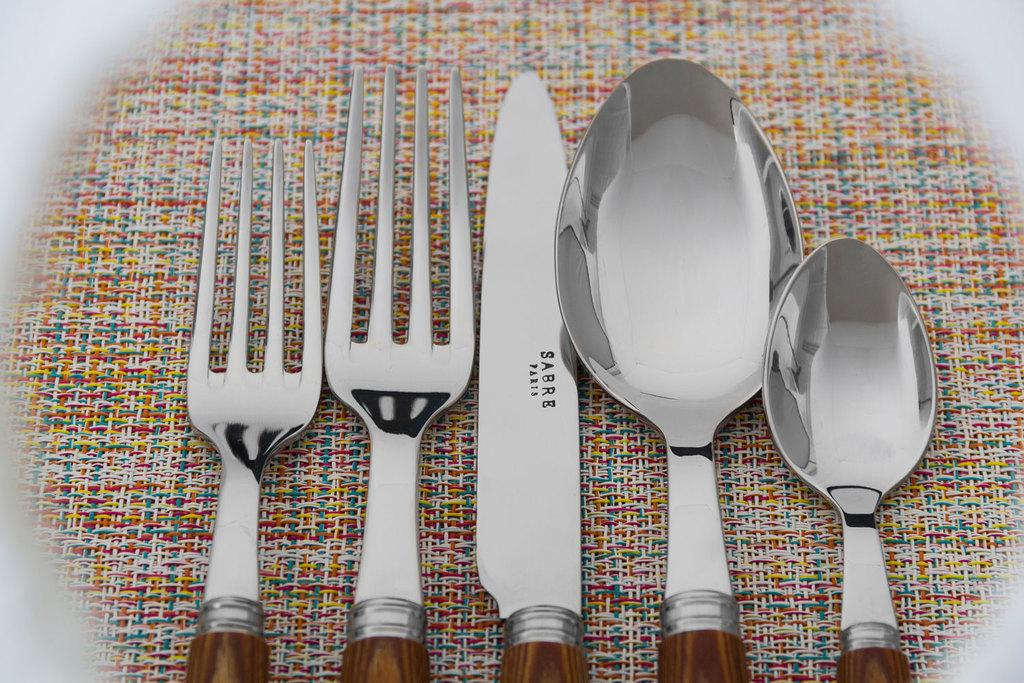What type of object is colorful and present in the image? There is a colorful object in the image. What utensils are attached to the object? The object has two forks, a knife, and two spoons. Who created the list that is visible in the image? There is no list present in the image. 